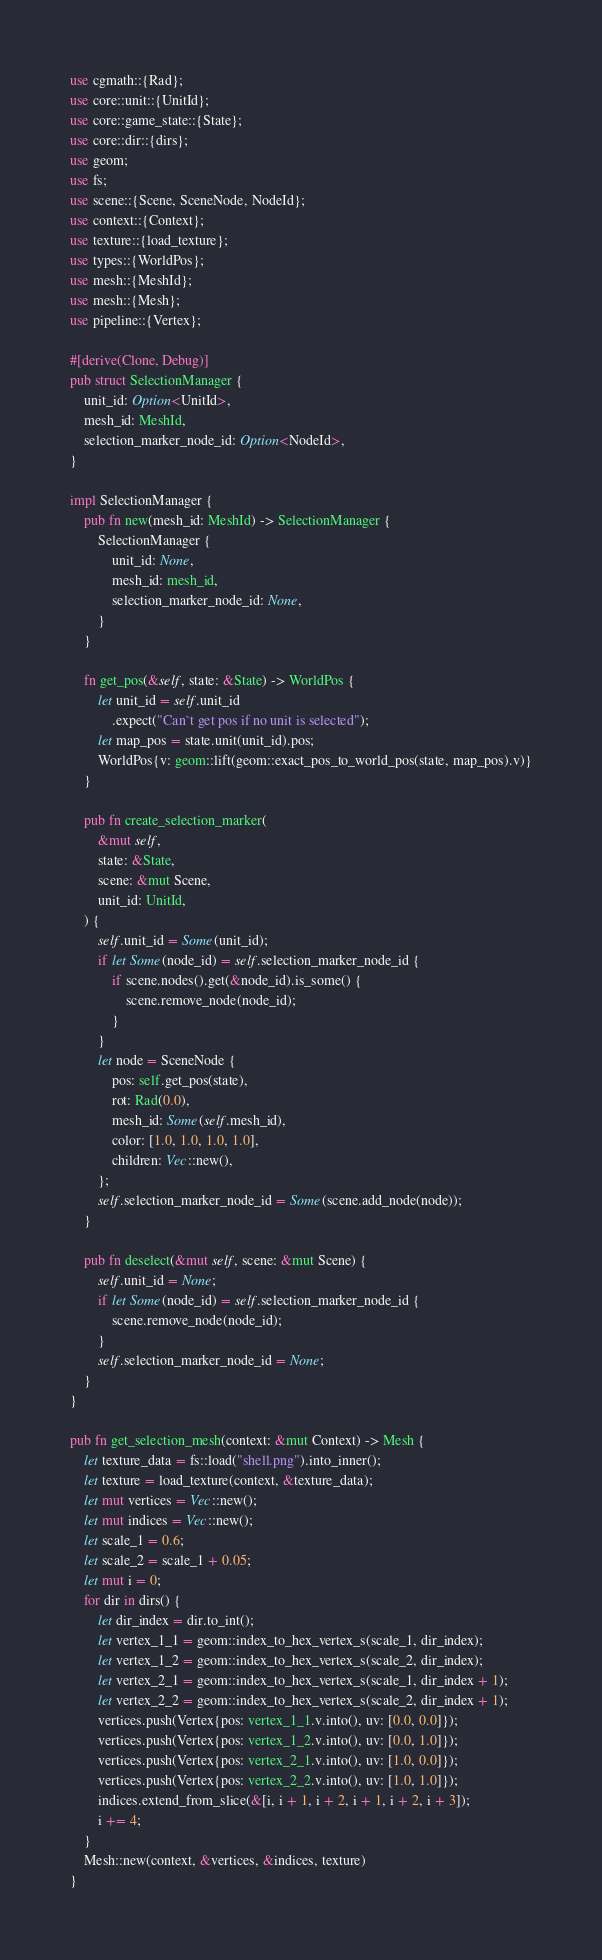<code> <loc_0><loc_0><loc_500><loc_500><_Rust_>use cgmath::{Rad};
use core::unit::{UnitId};
use core::game_state::{State};
use core::dir::{dirs};
use geom;
use fs;
use scene::{Scene, SceneNode, NodeId};
use context::{Context};
use texture::{load_texture};
use types::{WorldPos};
use mesh::{MeshId};
use mesh::{Mesh};
use pipeline::{Vertex};

#[derive(Clone, Debug)]
pub struct SelectionManager {
    unit_id: Option<UnitId>,
    mesh_id: MeshId,
    selection_marker_node_id: Option<NodeId>,
}

impl SelectionManager {
    pub fn new(mesh_id: MeshId) -> SelectionManager {
        SelectionManager {
            unit_id: None,
            mesh_id: mesh_id,
            selection_marker_node_id: None,
        }
    }

    fn get_pos(&self, state: &State) -> WorldPos {
        let unit_id = self.unit_id
            .expect("Can`t get pos if no unit is selected");
        let map_pos = state.unit(unit_id).pos;
        WorldPos{v: geom::lift(geom::exact_pos_to_world_pos(state, map_pos).v)}
    }

    pub fn create_selection_marker(
        &mut self,
        state: &State,
        scene: &mut Scene,
        unit_id: UnitId,
    ) {
        self.unit_id = Some(unit_id);
        if let Some(node_id) = self.selection_marker_node_id {
            if scene.nodes().get(&node_id).is_some() {
                scene.remove_node(node_id);
            }
        }
        let node = SceneNode {
            pos: self.get_pos(state),
            rot: Rad(0.0),
            mesh_id: Some(self.mesh_id),
            color: [1.0, 1.0, 1.0, 1.0],
            children: Vec::new(),
        };
        self.selection_marker_node_id = Some(scene.add_node(node));
    }

    pub fn deselect(&mut self, scene: &mut Scene) {
        self.unit_id = None;
        if let Some(node_id) = self.selection_marker_node_id {
            scene.remove_node(node_id);
        }
        self.selection_marker_node_id = None;
    }
}

pub fn get_selection_mesh(context: &mut Context) -> Mesh {
    let texture_data = fs::load("shell.png").into_inner();
    let texture = load_texture(context, &texture_data);
    let mut vertices = Vec::new();
    let mut indices = Vec::new();
    let scale_1 = 0.6;
    let scale_2 = scale_1 + 0.05;
    let mut i = 0;
    for dir in dirs() {
        let dir_index = dir.to_int();
        let vertex_1_1 = geom::index_to_hex_vertex_s(scale_1, dir_index);
        let vertex_1_2 = geom::index_to_hex_vertex_s(scale_2, dir_index);
        let vertex_2_1 = geom::index_to_hex_vertex_s(scale_1, dir_index + 1);
        let vertex_2_2 = geom::index_to_hex_vertex_s(scale_2, dir_index + 1);
        vertices.push(Vertex{pos: vertex_1_1.v.into(), uv: [0.0, 0.0]});
        vertices.push(Vertex{pos: vertex_1_2.v.into(), uv: [0.0, 1.0]});
        vertices.push(Vertex{pos: vertex_2_1.v.into(), uv: [1.0, 0.0]});
        vertices.push(Vertex{pos: vertex_2_2.v.into(), uv: [1.0, 1.0]});
        indices.extend_from_slice(&[i, i + 1, i + 2, i + 1, i + 2, i + 3]);
        i += 4;
    }
    Mesh::new(context, &vertices, &indices, texture)
}
</code> 